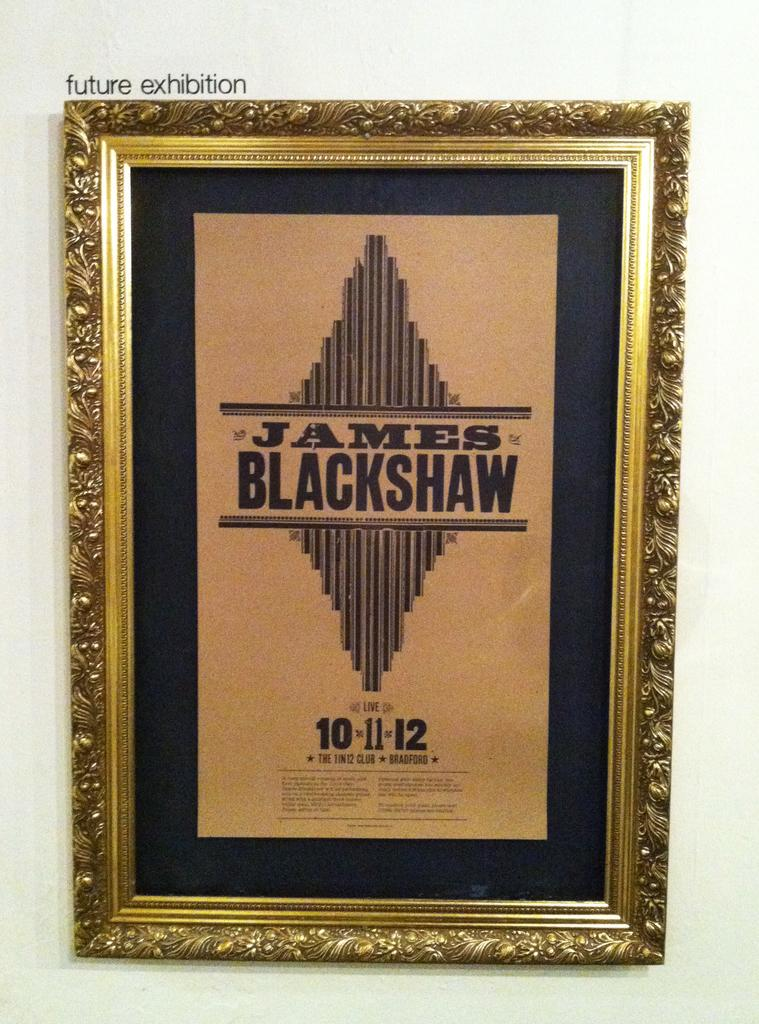Provide a one-sentence caption for the provided image. A decorative gold frame with a poster in the center that says James Blackshaw and the date 10.11.12. 